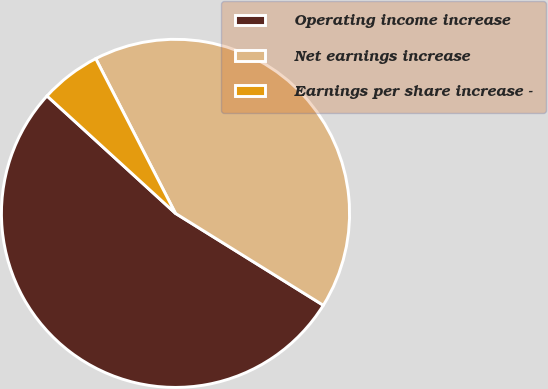Convert chart to OTSL. <chart><loc_0><loc_0><loc_500><loc_500><pie_chart><fcel>Operating income increase<fcel>Net earnings increase<fcel>Earnings per share increase -<nl><fcel>52.93%<fcel>41.43%<fcel>5.64%<nl></chart> 